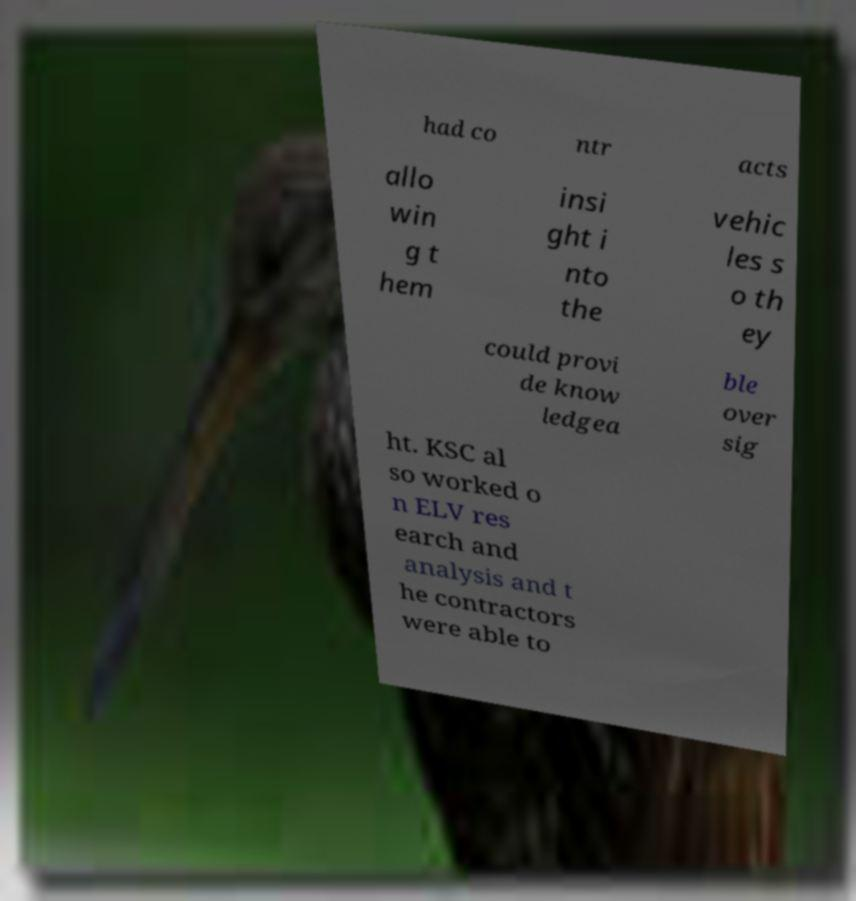I need the written content from this picture converted into text. Can you do that? had co ntr acts allo win g t hem insi ght i nto the vehic les s o th ey could provi de know ledgea ble over sig ht. KSC al so worked o n ELV res earch and analysis and t he contractors were able to 